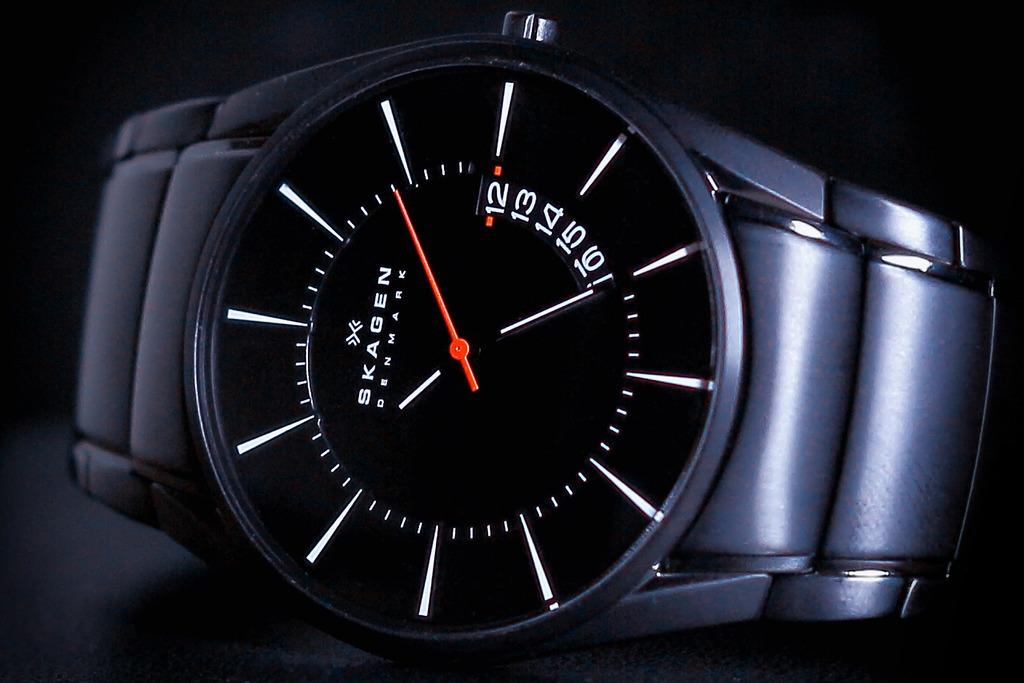<image>
Write a terse but informative summary of the picture. Black and white wristwatch which says SKAGEN on it. 